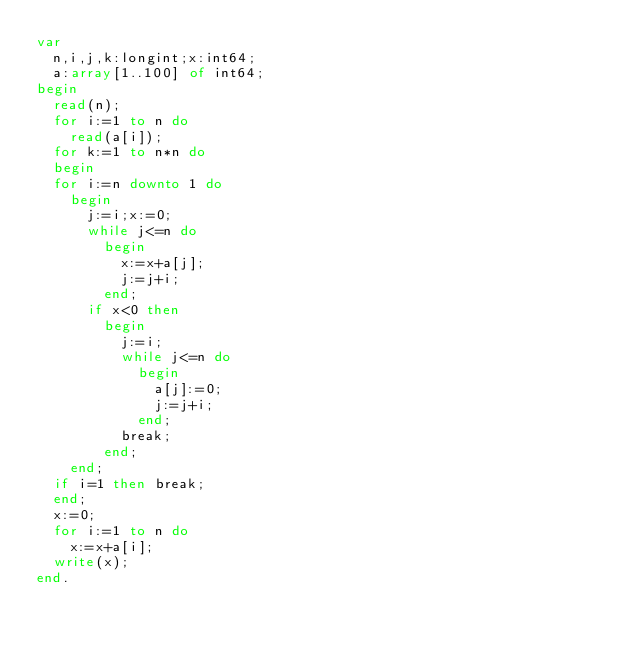Convert code to text. <code><loc_0><loc_0><loc_500><loc_500><_Pascal_>var
  n,i,j,k:longint;x:int64;
  a:array[1..100] of int64;
begin
  read(n);
  for i:=1 to n do
    read(a[i]);
  for k:=1 to n*n do
  begin
  for i:=n downto 1 do
    begin
      j:=i;x:=0;
      while j<=n do
        begin
          x:=x+a[j];
          j:=j+i;
        end;
      if x<0 then
        begin
          j:=i;
          while j<=n do
            begin
              a[j]:=0;
              j:=j+i;
            end;
          break;
        end;
    end;
  if i=1 then break;
  end;
  x:=0;
  for i:=1 to n do
    x:=x+a[i];
  write(x);
end.
</code> 